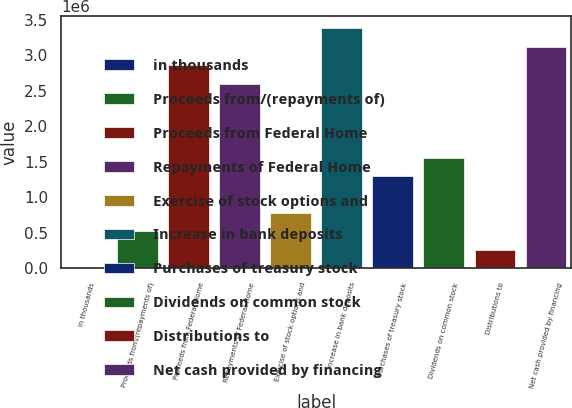<chart> <loc_0><loc_0><loc_500><loc_500><bar_chart><fcel>in thousands<fcel>Proceeds from/(repayments of)<fcel>Proceeds from Federal Home<fcel>Repayments of Federal Home<fcel>Exercise of stock options and<fcel>Increase in bank deposits<fcel>Purchases of treasury stock<fcel>Dividends on common stock<fcel>Distributions to<fcel>Net cash provided by financing<nl><fcel>2015<fcel>521813<fcel>2.86091e+06<fcel>2.60101e+06<fcel>781712<fcel>3.3807e+06<fcel>1.30151e+06<fcel>1.56141e+06<fcel>261914<fcel>3.1208e+06<nl></chart> 